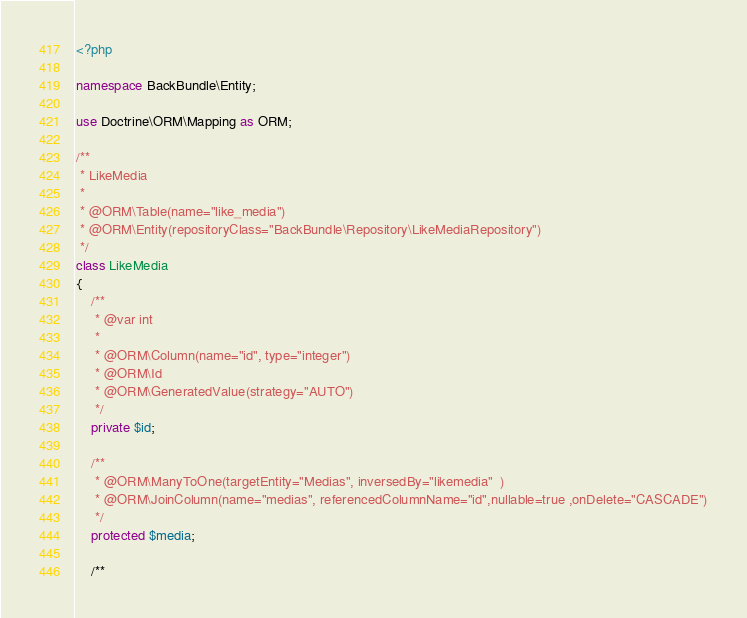<code> <loc_0><loc_0><loc_500><loc_500><_PHP_><?php

namespace BackBundle\Entity;

use Doctrine\ORM\Mapping as ORM;

/**
 * LikeMedia
 *
 * @ORM\Table(name="like_media")
 * @ORM\Entity(repositoryClass="BackBundle\Repository\LikeMediaRepository")
 */
class LikeMedia
{
    /**
     * @var int
     *
     * @ORM\Column(name="id", type="integer")
     * @ORM\Id
     * @ORM\GeneratedValue(strategy="AUTO")
     */
    private $id;

    /**
     * @ORM\ManyToOne(targetEntity="Medias", inversedBy="likemedia"  )
     * @ORM\JoinColumn(name="medias", referencedColumnName="id",nullable=true ,onDelete="CASCADE")
     */
    protected $media;

    /**</code> 